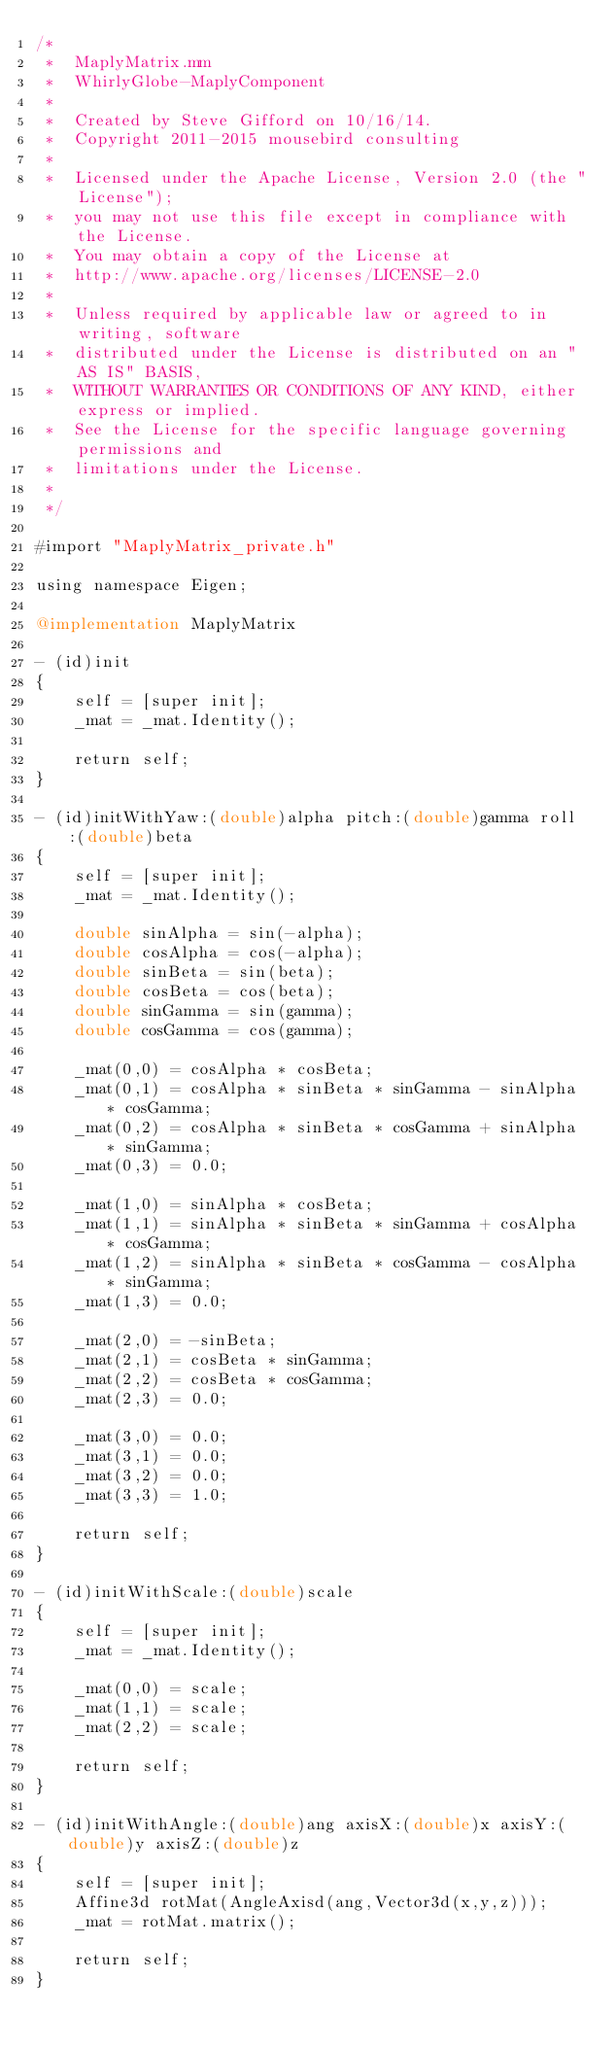Convert code to text. <code><loc_0><loc_0><loc_500><loc_500><_ObjectiveC_>/*
 *  MaplyMatrix.mm
 *  WhirlyGlobe-MaplyComponent
 *
 *  Created by Steve Gifford on 10/16/14.
 *  Copyright 2011-2015 mousebird consulting
 *
 *  Licensed under the Apache License, Version 2.0 (the "License");
 *  you may not use this file except in compliance with the License.
 *  You may obtain a copy of the License at
 *  http://www.apache.org/licenses/LICENSE-2.0
 *
 *  Unless required by applicable law or agreed to in writing, software
 *  distributed under the License is distributed on an "AS IS" BASIS,
 *  WITHOUT WARRANTIES OR CONDITIONS OF ANY KIND, either express or implied.
 *  See the License for the specific language governing permissions and
 *  limitations under the License.
 *
 */

#import "MaplyMatrix_private.h"

using namespace Eigen;

@implementation MaplyMatrix

- (id)init
{
    self = [super init];
    _mat = _mat.Identity();
    
    return self;
}

- (id)initWithYaw:(double)alpha pitch:(double)gamma roll:(double)beta
{
    self = [super init];
    _mat = _mat.Identity();
    
    double sinAlpha = sin(-alpha);
    double cosAlpha = cos(-alpha);
    double sinBeta = sin(beta);
    double cosBeta = cos(beta);
    double sinGamma = sin(gamma);
    double cosGamma = cos(gamma);
    
    _mat(0,0) = cosAlpha * cosBeta;
    _mat(0,1) = cosAlpha * sinBeta * sinGamma - sinAlpha * cosGamma;
    _mat(0,2) = cosAlpha * sinBeta * cosGamma + sinAlpha * sinGamma;
    _mat(0,3) = 0.0;
    
    _mat(1,0) = sinAlpha * cosBeta;
    _mat(1,1) = sinAlpha * sinBeta * sinGamma + cosAlpha * cosGamma;
    _mat(1,2) = sinAlpha * sinBeta * cosGamma - cosAlpha * sinGamma;
    _mat(1,3) = 0.0;
    
    _mat(2,0) = -sinBeta;
    _mat(2,1) = cosBeta * sinGamma;
    _mat(2,2) = cosBeta * cosGamma;
    _mat(2,3) = 0.0;
    
    _mat(3,0) = 0.0;
    _mat(3,1) = 0.0;
    _mat(3,2) = 0.0;
    _mat(3,3) = 1.0;
    
    return self;
}

- (id)initWithScale:(double)scale
{
    self = [super init];
    _mat = _mat.Identity();
    
    _mat(0,0) = scale;
    _mat(1,1) = scale;
    _mat(2,2) = scale;
    
    return self;
}

- (id)initWithAngle:(double)ang axisX:(double)x axisY:(double)y axisZ:(double)z
{
    self = [super init];
    Affine3d rotMat(AngleAxisd(ang,Vector3d(x,y,z)));
    _mat = rotMat.matrix();
    
    return self;
}
</code> 